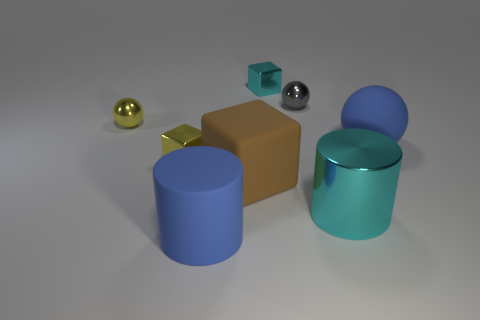How many other matte things have the same shape as the tiny cyan thing?
Offer a very short reply. 1. Does the big rubber cylinder have the same color as the big rubber thing on the right side of the gray shiny sphere?
Your response must be concise. Yes. Does the tiny gray thing have the same material as the big blue object that is right of the large blue rubber cylinder?
Provide a short and direct response. No. Is there a matte cylinder that has the same color as the large sphere?
Provide a succinct answer. Yes. What is the shape of the small metallic thing that is both to the right of the brown object and in front of the cyan metal block?
Keep it short and to the point. Sphere. The tiny object left of the small cube in front of the large blue matte sphere is what shape?
Keep it short and to the point. Sphere. Does the brown matte thing have the same shape as the small gray shiny thing?
Provide a succinct answer. No. There is a large cylinder that is the same color as the large sphere; what is its material?
Provide a short and direct response. Rubber. Do the large rubber cube and the shiny cylinder have the same color?
Your answer should be compact. No. There is a big object that is in front of the cyan thing in front of the tiny yellow shiny ball; how many small metallic balls are in front of it?
Your answer should be very brief. 0. 